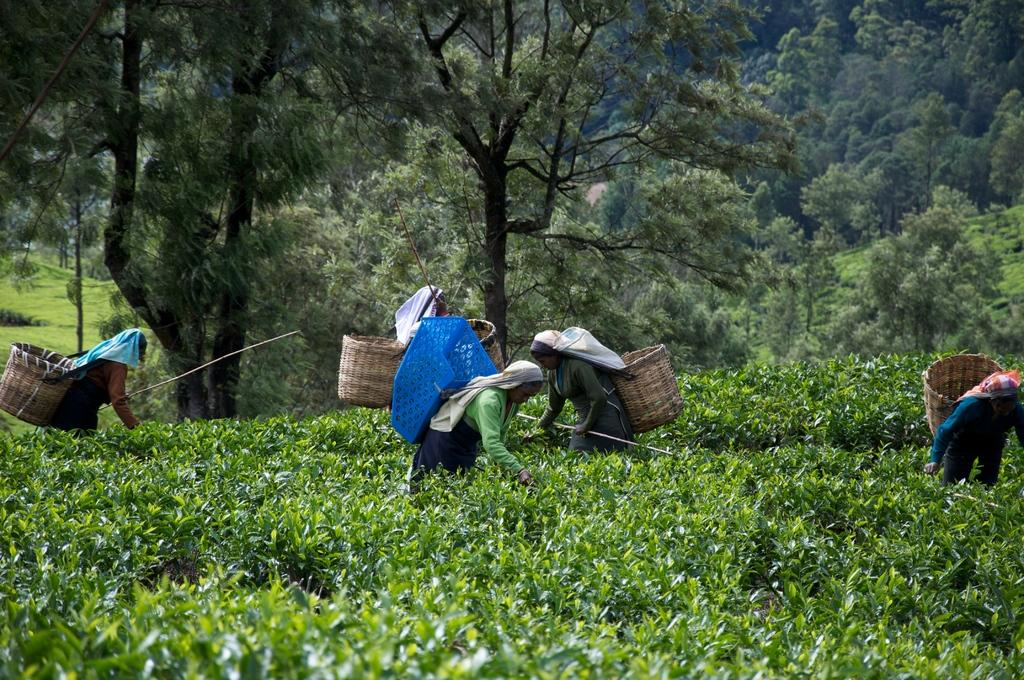How many people can be seen in the image? There are many people standing in the image. What are the people wearing? The people are wearing clothes. What are the people carrying in the image? The people are carrying a wooden basket. What type of plants can be seen in the image? There are tea plants in the image. What type of vegetation is visible in the image? There is grass visible in the image. What other natural elements can be seen in the image? There are trees in the image. Are there any dinosaurs visible in the image? No, there are no dinosaurs present in the image. Can you tell me how the people are blowing the tea plants in the image? There is no indication in the image that the people are blowing the tea plants; they are simply carrying a wooden basket. 